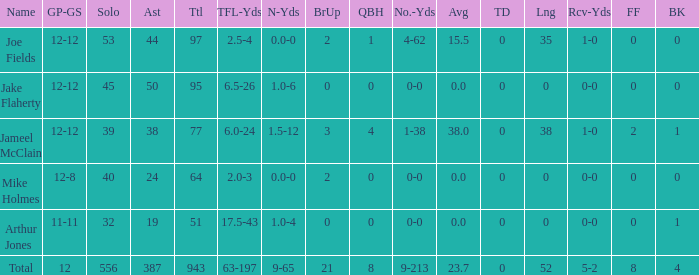What is the largest number of tds scored for a player? 0.0. 